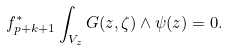Convert formula to latex. <formula><loc_0><loc_0><loc_500><loc_500>f _ { p + k + 1 } ^ { * } \int _ { V _ { z } } G ( z , \zeta ) \wedge \psi ( z ) = 0 .</formula> 